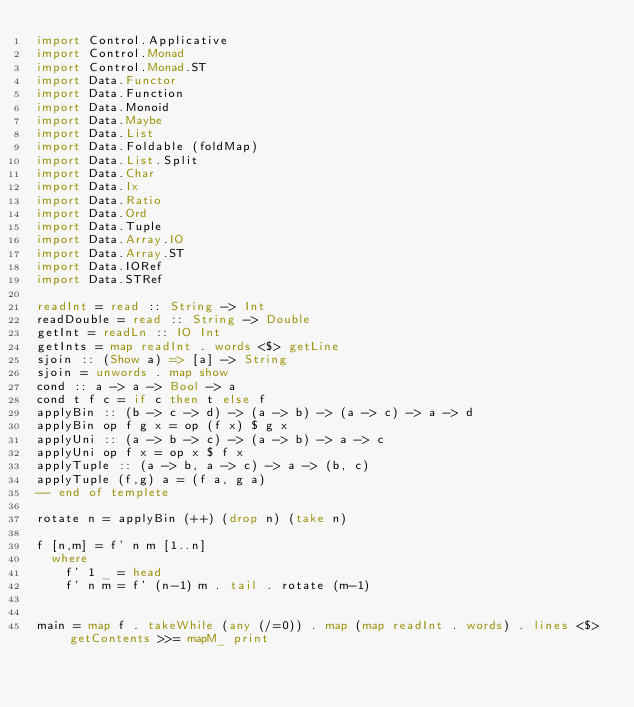<code> <loc_0><loc_0><loc_500><loc_500><_Haskell_>import Control.Applicative
import Control.Monad
import Control.Monad.ST
import Data.Functor
import Data.Function
import Data.Monoid
import Data.Maybe
import Data.List
import Data.Foldable (foldMap)
import Data.List.Split
import Data.Char
import Data.Ix
import Data.Ratio
import Data.Ord
import Data.Tuple
import Data.Array.IO
import Data.Array.ST
import Data.IORef
import Data.STRef
 
readInt = read :: String -> Int
readDouble = read :: String -> Double
getInt = readLn :: IO Int
getInts = map readInt . words <$> getLine
sjoin :: (Show a) => [a] -> String
sjoin = unwords . map show
cond :: a -> a -> Bool -> a
cond t f c = if c then t else f
applyBin :: (b -> c -> d) -> (a -> b) -> (a -> c) -> a -> d
applyBin op f g x = op (f x) $ g x
applyUni :: (a -> b -> c) -> (a -> b) -> a -> c
applyUni op f x = op x $ f x
applyTuple :: (a -> b, a -> c) -> a -> (b, c)
applyTuple (f,g) a = (f a, g a)
-- end of templete

rotate n = applyBin (++) (drop n) (take n)

f [n,m] = f' n m [1..n]
  where
    f' 1 _ = head
    f' n m = f' (n-1) m . tail . rotate (m-1)


main = map f . takeWhile (any (/=0)) . map (map readInt . words) . lines <$> getContents >>= mapM_ print</code> 